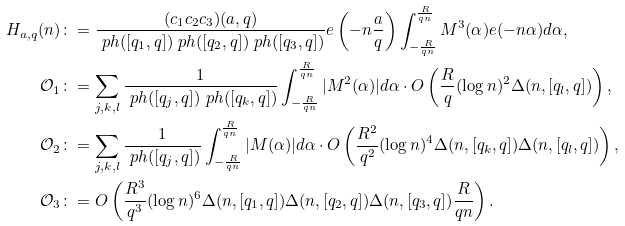<formula> <loc_0><loc_0><loc_500><loc_500>H _ { a , q } ( n ) & \colon = \frac { ( c _ { 1 } c _ { 2 } c _ { 3 } ) ( a , q ) } { \ p h ( [ q _ { 1 } , q ] ) \ p h ( [ q _ { 2 } , q ] ) \ p h ( [ q _ { 3 } , q ] ) } e \left ( - n \frac { a } { q } \right ) \int _ { - \frac { R } { q n } } ^ { \frac { R } { q n } } M ^ { 3 } ( \alpha ) e ( - n \alpha ) d \alpha , \\ \mathcal { O } _ { 1 } & \colon = \sum _ { j , k , l } \frac { 1 } { \ p h ( [ q _ { j } , q ] ) \ p h ( [ q _ { k } , q ] ) } \int _ { - \frac { R } { q n } } ^ { \frac { R } { q n } } | M ^ { 2 } ( \alpha ) | d \alpha \cdot O \left ( \frac { R } { q } ( \log n ) ^ { 2 } \Delta ( n , [ q _ { l } , q ] ) \right ) , \\ \mathcal { O } _ { 2 } & \colon = \sum _ { j , k , l } \frac { 1 } { \ p h ( [ q _ { j } , q ] ) } \int _ { - \frac { R } { q n } } ^ { \frac { R } { q n } } | M ( \alpha ) | d \alpha \cdot O \left ( \frac { R ^ { 2 } } { q ^ { 2 } } ( \log n ) ^ { 4 } \Delta ( n , [ q _ { k } , q ] ) \Delta ( n , [ q _ { l } , q ] ) \right ) , \\ \mathcal { O } _ { 3 } & \colon = O \left ( \frac { R ^ { 3 } } { q ^ { 3 } } ( \log n ) ^ { 6 } \Delta ( n , [ q _ { 1 } , q ] ) \Delta ( n , [ q _ { 2 } , q ] ) \Delta ( n , [ q _ { 3 } , q ] ) \frac { R } { q n } \right ) .</formula> 